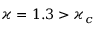<formula> <loc_0><loc_0><loc_500><loc_500>\varkappa = 1 . 3 > \varkappa _ { c }</formula> 